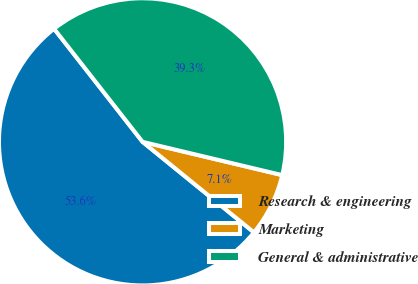Convert chart. <chart><loc_0><loc_0><loc_500><loc_500><pie_chart><fcel>Research & engineering<fcel>Marketing<fcel>General & administrative<nl><fcel>53.57%<fcel>7.14%<fcel>39.29%<nl></chart> 